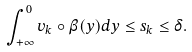<formula> <loc_0><loc_0><loc_500><loc_500>\int _ { + \infty } ^ { 0 } v _ { k } \circ \beta ( y ) d y \leq s _ { k } \leq \delta .</formula> 